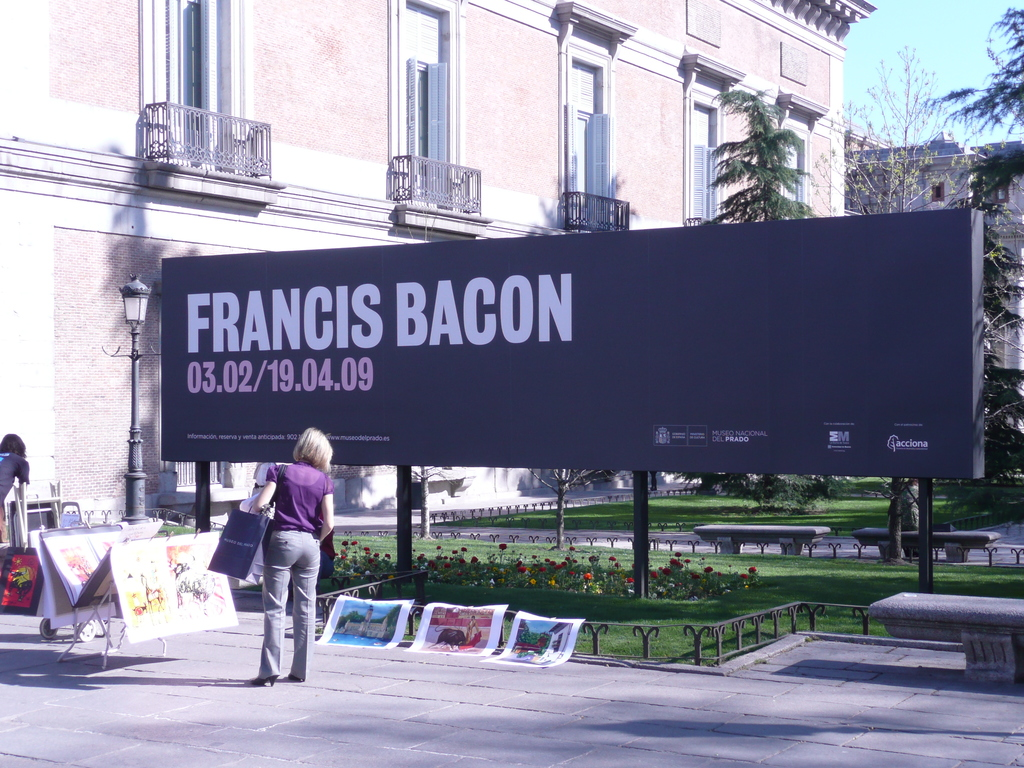Discuss the significance of exhibiting Francis Bacon's work at the Museo Nacional del Prado. Exhibiting Francis Bacon's work at the Museo Nacional del Prado is significant as it brings the radical and emotional intensity of Bacon's art to a historically classic art venue, offering visitors a contrast between traditional and modernist expressions of human conditions. 